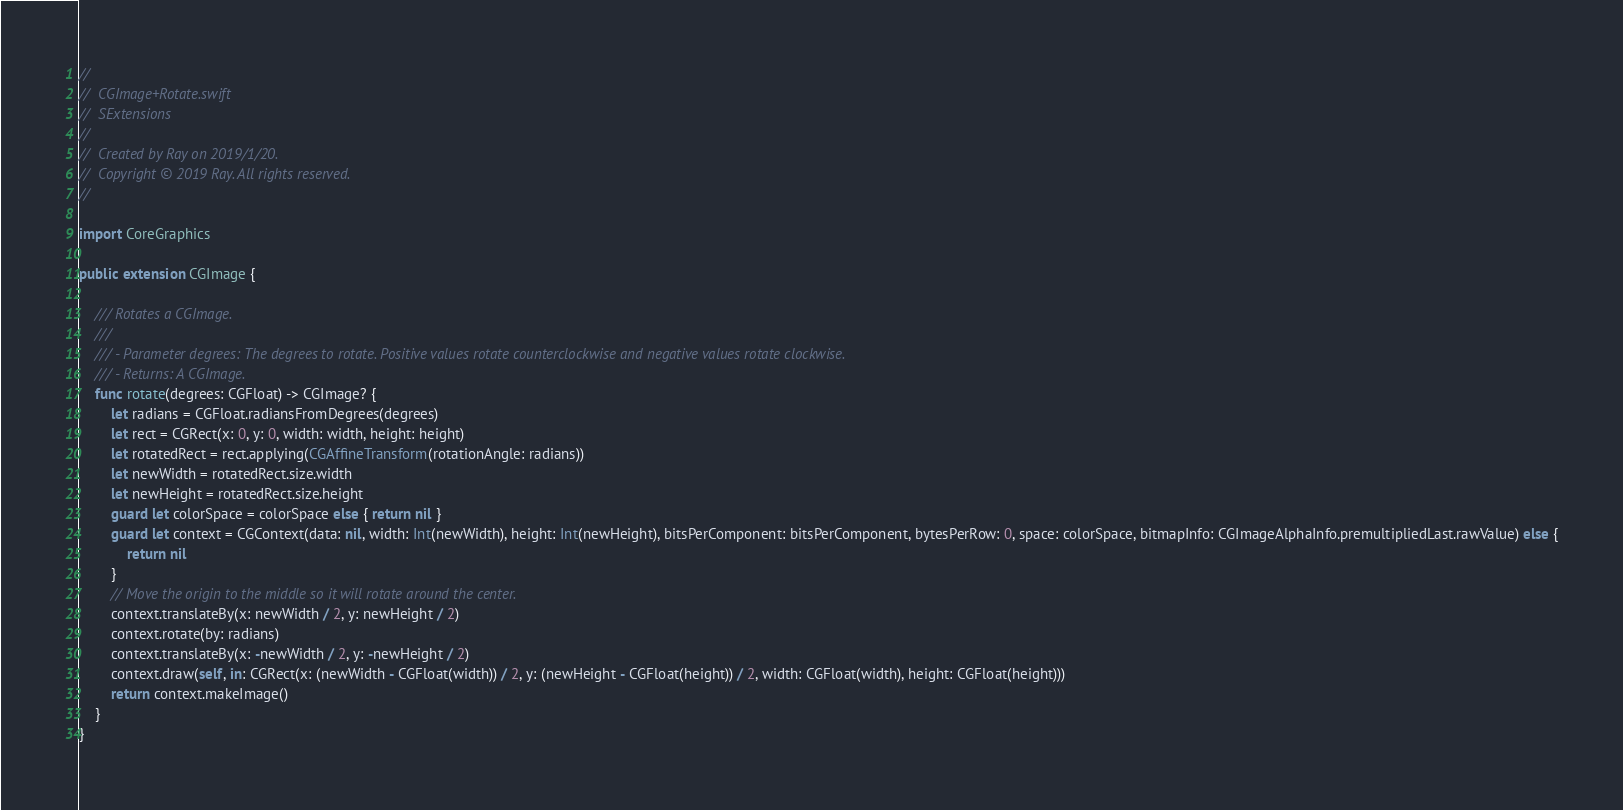<code> <loc_0><loc_0><loc_500><loc_500><_Swift_>//
//  CGImage+Rotate.swift
//  SExtensions
//
//  Created by Ray on 2019/1/20.
//  Copyright © 2019 Ray. All rights reserved.
//

import CoreGraphics

public extension CGImage {

    /// Rotates a CGImage.
    ///
    /// - Parameter degrees: The degrees to rotate. Positive values rotate counterclockwise and negative values rotate clockwise.
    /// - Returns: A CGImage.
    func rotate(degrees: CGFloat) -> CGImage? {
        let radians = CGFloat.radiansFromDegrees(degrees)
        let rect = CGRect(x: 0, y: 0, width: width, height: height)
        let rotatedRect = rect.applying(CGAffineTransform(rotationAngle: radians))
        let newWidth = rotatedRect.size.width
        let newHeight = rotatedRect.size.height
        guard let colorSpace = colorSpace else { return nil }
        guard let context = CGContext(data: nil, width: Int(newWidth), height: Int(newHeight), bitsPerComponent: bitsPerComponent, bytesPerRow: 0, space: colorSpace, bitmapInfo: CGImageAlphaInfo.premultipliedLast.rawValue) else {
            return nil
        }
        // Move the origin to the middle so it will rotate around the center.
        context.translateBy(x: newWidth / 2, y: newHeight / 2)
        context.rotate(by: radians)
        context.translateBy(x: -newWidth / 2, y: -newHeight / 2)
        context.draw(self, in: CGRect(x: (newWidth - CGFloat(width)) / 2, y: (newHeight - CGFloat(height)) / 2, width: CGFloat(width), height: CGFloat(height)))
        return context.makeImage()
    }
}
</code> 